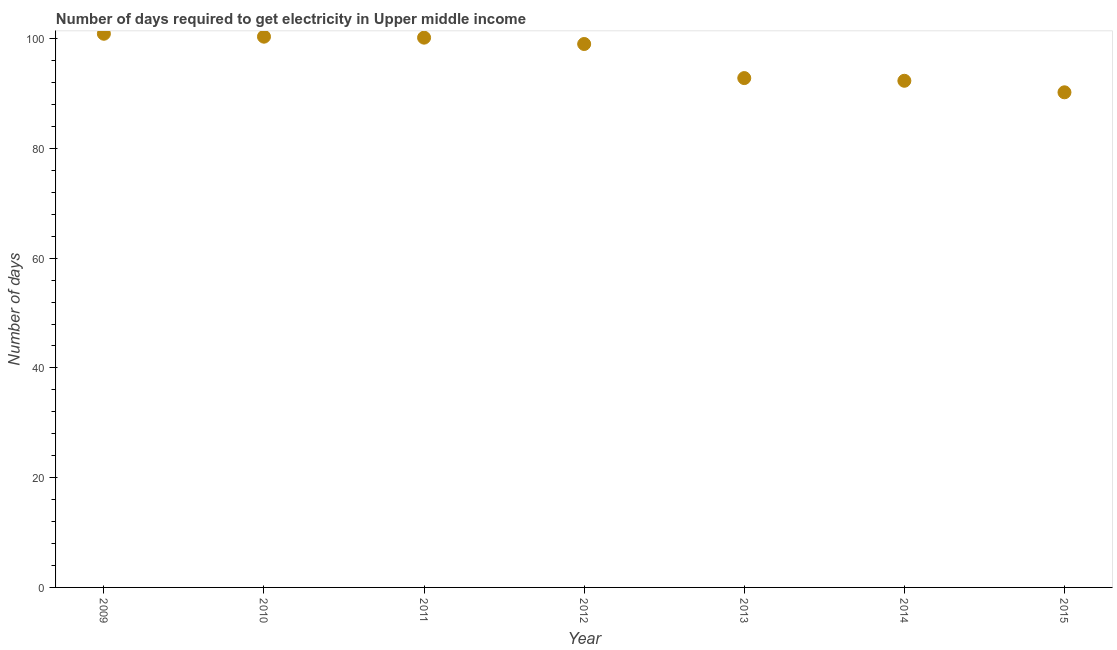What is the time to get electricity in 2014?
Your response must be concise. 92.32. Across all years, what is the maximum time to get electricity?
Your response must be concise. 100.89. Across all years, what is the minimum time to get electricity?
Keep it short and to the point. 90.22. In which year was the time to get electricity minimum?
Ensure brevity in your answer.  2015. What is the sum of the time to get electricity?
Provide a short and direct response. 675.79. What is the difference between the time to get electricity in 2011 and 2012?
Your answer should be compact. 1.16. What is the average time to get electricity per year?
Ensure brevity in your answer.  96.54. What is the median time to get electricity?
Ensure brevity in your answer.  99.02. In how many years, is the time to get electricity greater than 52 ?
Make the answer very short. 7. Do a majority of the years between 2011 and 2014 (inclusive) have time to get electricity greater than 56 ?
Provide a short and direct response. Yes. What is the ratio of the time to get electricity in 2011 to that in 2014?
Ensure brevity in your answer.  1.09. Is the time to get electricity in 2014 less than that in 2015?
Make the answer very short. No. What is the difference between the highest and the second highest time to get electricity?
Ensure brevity in your answer.  0.53. What is the difference between the highest and the lowest time to get electricity?
Offer a very short reply. 10.67. How many dotlines are there?
Provide a succinct answer. 1. Are the values on the major ticks of Y-axis written in scientific E-notation?
Your answer should be very brief. No. Does the graph contain any zero values?
Offer a terse response. No. Does the graph contain grids?
Your answer should be compact. No. What is the title of the graph?
Provide a short and direct response. Number of days required to get electricity in Upper middle income. What is the label or title of the Y-axis?
Provide a short and direct response. Number of days. What is the Number of days in 2009?
Your answer should be very brief. 100.89. What is the Number of days in 2010?
Your answer should be very brief. 100.36. What is the Number of days in 2011?
Provide a succinct answer. 100.18. What is the Number of days in 2012?
Provide a succinct answer. 99.02. What is the Number of days in 2013?
Provide a succinct answer. 92.81. What is the Number of days in 2014?
Ensure brevity in your answer.  92.32. What is the Number of days in 2015?
Your answer should be compact. 90.22. What is the difference between the Number of days in 2009 and 2010?
Your response must be concise. 0.53. What is the difference between the Number of days in 2009 and 2011?
Your answer should be very brief. 0.71. What is the difference between the Number of days in 2009 and 2012?
Give a very brief answer. 1.87. What is the difference between the Number of days in 2009 and 2013?
Provide a succinct answer. 8.08. What is the difference between the Number of days in 2009 and 2014?
Give a very brief answer. 8.57. What is the difference between the Number of days in 2009 and 2015?
Ensure brevity in your answer.  10.67. What is the difference between the Number of days in 2010 and 2011?
Make the answer very short. 0.18. What is the difference between the Number of days in 2010 and 2012?
Give a very brief answer. 1.33. What is the difference between the Number of days in 2010 and 2013?
Keep it short and to the point. 7.55. What is the difference between the Number of days in 2010 and 2014?
Ensure brevity in your answer.  8.04. What is the difference between the Number of days in 2010 and 2015?
Provide a short and direct response. 10.14. What is the difference between the Number of days in 2011 and 2012?
Give a very brief answer. 1.16. What is the difference between the Number of days in 2011 and 2013?
Your response must be concise. 7.37. What is the difference between the Number of days in 2011 and 2014?
Your response must be concise. 7.86. What is the difference between the Number of days in 2011 and 2015?
Offer a terse response. 9.96. What is the difference between the Number of days in 2012 and 2013?
Offer a terse response. 6.21. What is the difference between the Number of days in 2012 and 2014?
Your answer should be compact. 6.7. What is the difference between the Number of days in 2012 and 2015?
Ensure brevity in your answer.  8.8. What is the difference between the Number of days in 2013 and 2014?
Your answer should be very brief. 0.49. What is the difference between the Number of days in 2013 and 2015?
Your response must be concise. 2.59. What is the difference between the Number of days in 2014 and 2015?
Provide a short and direct response. 2.1. What is the ratio of the Number of days in 2009 to that in 2011?
Offer a very short reply. 1.01. What is the ratio of the Number of days in 2009 to that in 2013?
Make the answer very short. 1.09. What is the ratio of the Number of days in 2009 to that in 2014?
Give a very brief answer. 1.09. What is the ratio of the Number of days in 2009 to that in 2015?
Provide a short and direct response. 1.12. What is the ratio of the Number of days in 2010 to that in 2011?
Offer a terse response. 1. What is the ratio of the Number of days in 2010 to that in 2012?
Make the answer very short. 1.01. What is the ratio of the Number of days in 2010 to that in 2013?
Make the answer very short. 1.08. What is the ratio of the Number of days in 2010 to that in 2014?
Give a very brief answer. 1.09. What is the ratio of the Number of days in 2010 to that in 2015?
Your answer should be compact. 1.11. What is the ratio of the Number of days in 2011 to that in 2012?
Provide a short and direct response. 1.01. What is the ratio of the Number of days in 2011 to that in 2013?
Offer a terse response. 1.08. What is the ratio of the Number of days in 2011 to that in 2014?
Ensure brevity in your answer.  1.08. What is the ratio of the Number of days in 2011 to that in 2015?
Offer a terse response. 1.11. What is the ratio of the Number of days in 2012 to that in 2013?
Your answer should be compact. 1.07. What is the ratio of the Number of days in 2012 to that in 2014?
Provide a short and direct response. 1.07. What is the ratio of the Number of days in 2012 to that in 2015?
Make the answer very short. 1.1. What is the ratio of the Number of days in 2013 to that in 2015?
Provide a short and direct response. 1.03. 